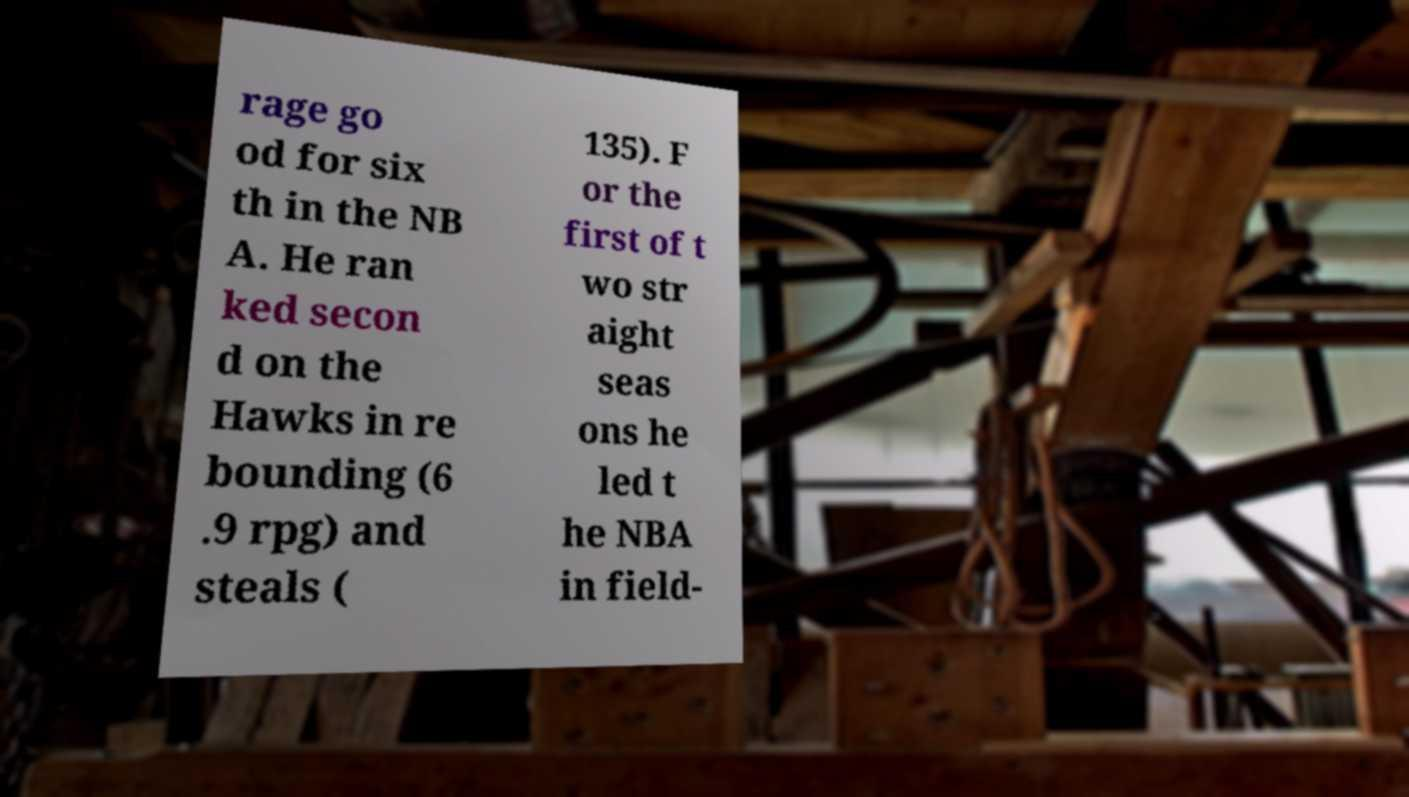I need the written content from this picture converted into text. Can you do that? rage go od for six th in the NB A. He ran ked secon d on the Hawks in re bounding (6 .9 rpg) and steals ( 135). F or the first of t wo str aight seas ons he led t he NBA in field- 